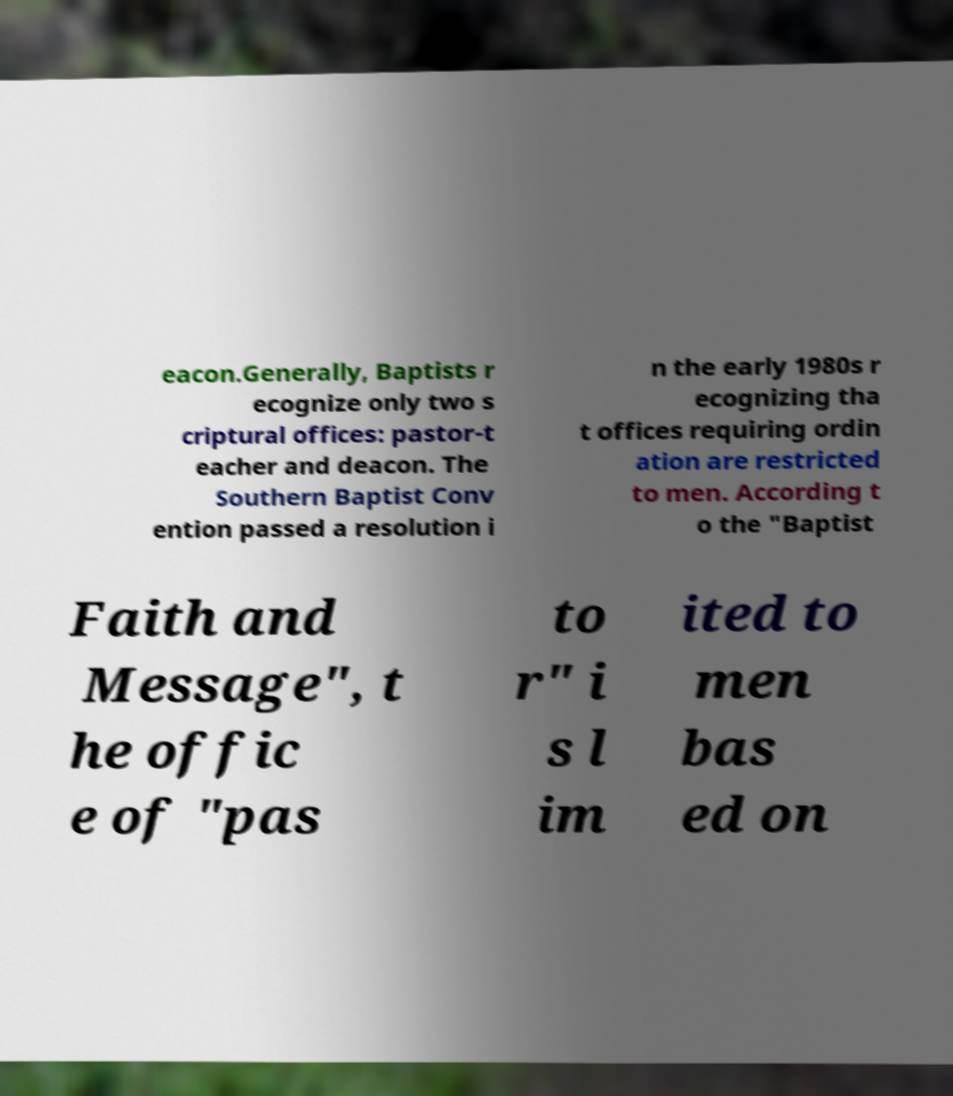What messages or text are displayed in this image? I need them in a readable, typed format. eacon.Generally, Baptists r ecognize only two s criptural offices: pastor-t eacher and deacon. The Southern Baptist Conv ention passed a resolution i n the early 1980s r ecognizing tha t offices requiring ordin ation are restricted to men. According t o the "Baptist Faith and Message", t he offic e of "pas to r" i s l im ited to men bas ed on 